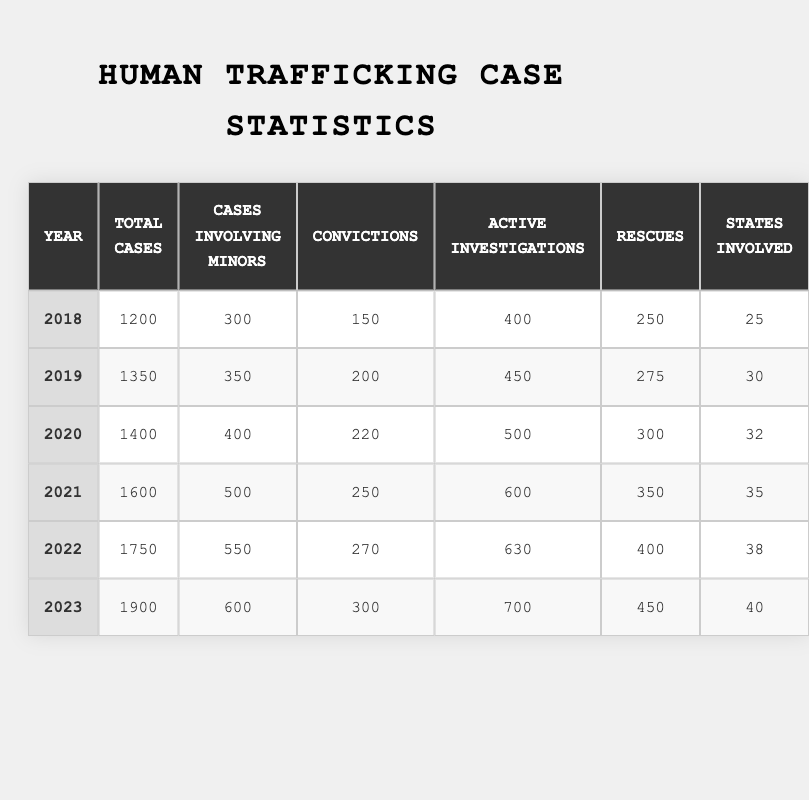What year had the highest total number of human trafficking cases? The table shows a year-on-year breakdown of total cases. The total cases for each year are: 1200 (2018), 1350 (2019), 1400 (2020), 1600 (2021), 1750 (2022), and 1900 (2023). The highest value is 1900 in the year 2023.
Answer: 2023 How many cases involving minors were reported in 2020? Referring to the table, under the year 2020, the number of cases involving minors is directly listed as 400.
Answer: 400 What is the average number of rescues over the years 2018 to 2023? The total rescues from 2018 to 2023 are 250, 275, 300, 350, 400, and 450. Summing these gives 2025. There are 6 years, so the average is 2025 divided by 6, which equals 337.5.
Answer: 337.5 Did the number of convictions increase every year from 2018 to 2023? Looking at the convictions each year: 150 (2018), 200 (2019), 220 (2020), 250 (2021), 270 (2022), and 300 (2023), we see that each year the number increased. Thus, the statement is true.
Answer: Yes What is the difference in total cases between the year 2018 and 2023? For 2018, the total cases are 1200. For 2023, it is 1900. The difference is 1900 - 1200 = 700.
Answer: 700 How many states were involved in human trafficking investigations in 2022 compared to 2019? In 2022, there were 38 states involved and in 2019 there were 30 states. The comparison shows an increase of 8 states from 2019 to 2022.
Answer: Increased by 8 states Was the number of active investigations greater in 2021 than the number of rescues in 2019? In 2021, the active investigations numbered 600 while the rescues in 2019 were 275. Since 600 > 275, the statement is true.
Answer: Yes What was the total number of investigations and rescues combined in 2023? In 2023, the total investigations were 700 and the rescues were 450. Adding these together gives 700 + 450 = 1150.
Answer: 1150 Calculate the percentage increase in the total number of human trafficking cases from 2018 to 2023. In 2018, there were 1200 total cases, and in 2023 there are 1900. The increase is (1900 - 1200) / 1200 * 100 = 58.33%.
Answer: 58.33% How many more cases involving minors were there in 2021 than in 2018? The number of cases involving minors in 2021 is 500 and in 2018 it is 300. The difference is 500 - 300 = 200.
Answer: 200 In which year was the least number of convictions recorded? The convictions for each year are: 150 (2018), 200 (2019), 220 (2020), 250 (2021), 270 (2022), and 300 (2023). The lowest number is 150 in 2018.
Answer: 2018 